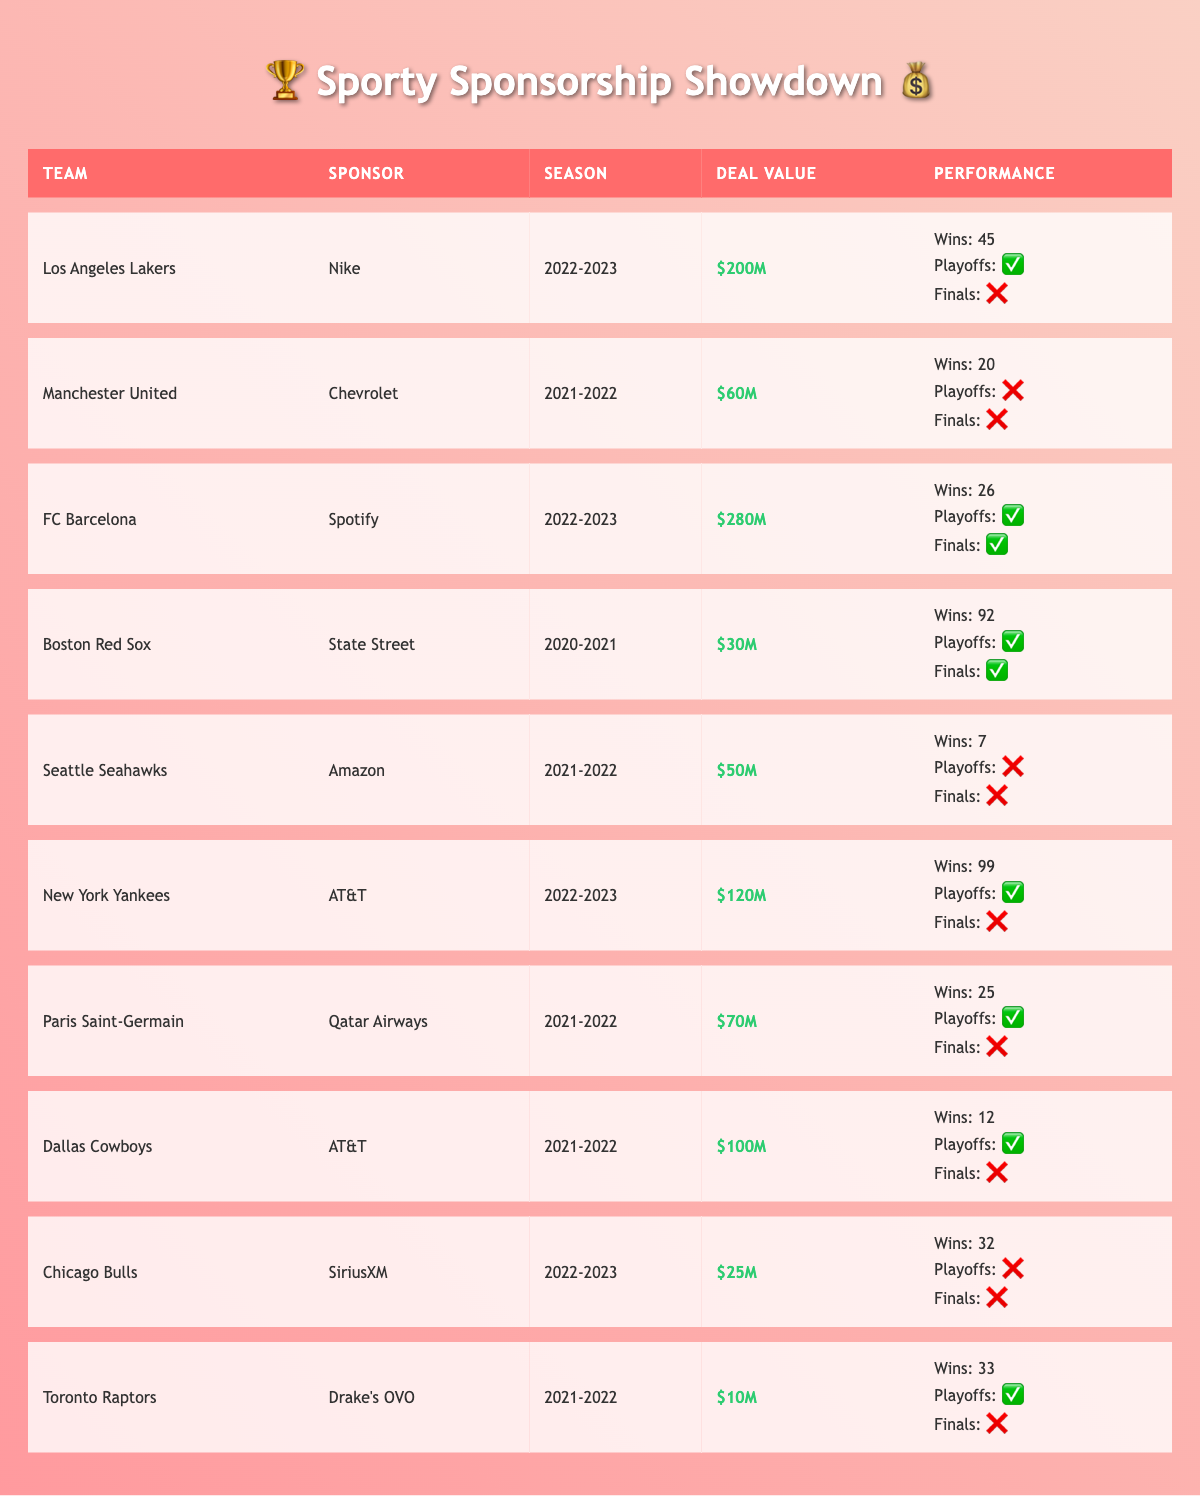What team had the highest sponsorship deal value in the table? The table shows that FC Barcelona has the highest sponsorship deal value of $280 million.
Answer: FC Barcelona How many teams made it to the playoffs during the 2021-2022 season? In the 2021-2022 season, three teams made it to the playoffs: Paris Saint-Germain, Dallas Cowboys, and Toronto Raptors, which can be confirmed by checking their playoff appearances.
Answer: 3 What is the total number of wins for teams that had sponsorship deals with AT&T? The teams sponsored by AT&T are the New York Yankees and Dallas Cowboys, with wins of 99 and 12, respectively. Adding these gives a total of 99 + 12 = 111 wins.
Answer: 111 Did the Los Angeles Lakers reach the finals in the 2022-2023 season? The table indicates that the Los Angeles Lakers did not reach the finals in the 2022-2023 season, as marked by a "❌" in the finals row.
Answer: No Which team won the most games in the 2020-2021 season? The Boston Red Sox won the most games, with a total of 92 wins in the 2020-2021 season, making this information easy to verify from the performance metrics.
Answer: Boston Red Sox Is it true that all teams with a sponsorship deal value over $100 million made it to the playoffs? No, not all teams with a deal value over $100 million made it to the playoffs. The New York Yankees had a deal worth $120 million and made it to the playoffs, but the Los Angeles Lakers had a $200 million deal and also made it to the playoffs. So, the statement is inaccurate, and context must be considered for each year's performance.
Answer: No What was the difference in wins between FC Barcelona and Manchester United in their respective seasons? FC Barcelona won 26 games in the 2022-2023 season, while Manchester United won 20 games in the 2021-2022 season. To find the difference, we calculate 26 - 20 = 6.
Answer: 6 How many teams reached the finals in their respective seasons according to the table? There are two teams that reached the finals: Boston Red Sox and FC Barcelona, which can be identified by checking the finals columns in the table.
Answer: 2 What is the average deal value of teams that did not reach the playoffs? The teams that did not reach the playoffs were Manchester United ($60M), Seattle Seahawks ($50M), and Chicago Bulls ($25M), so the total deal value is 60 + 50 + 25 = 135 million. There are 3 teams, thus the average is 135 / 3 = 45 million.
Answer: 45 million 